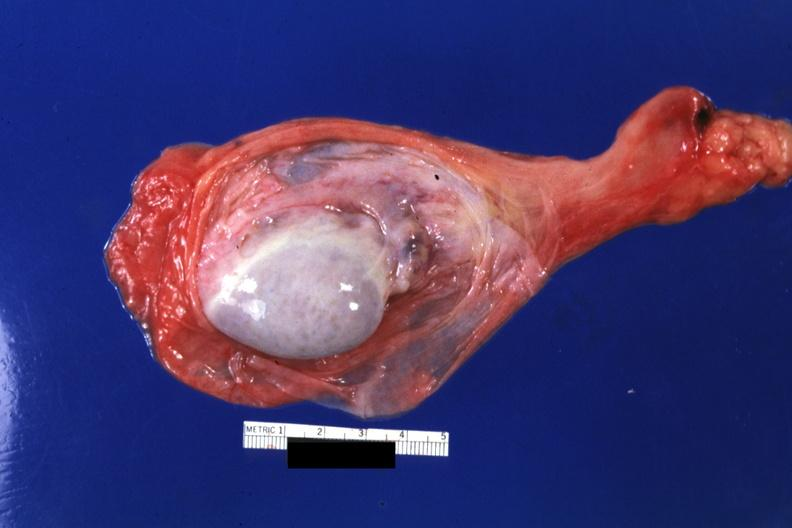what does this image show?
Answer the question using a single word or phrase. Sac opened 